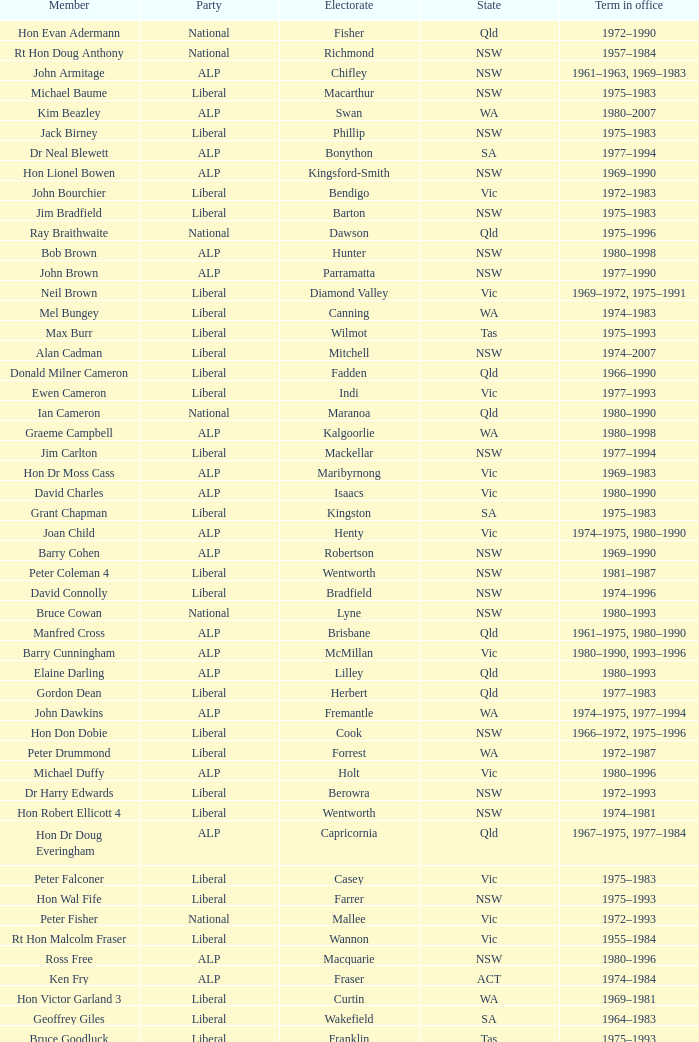Which party had a member from the state of Vic and an Electorate called Wannon? Liberal. 